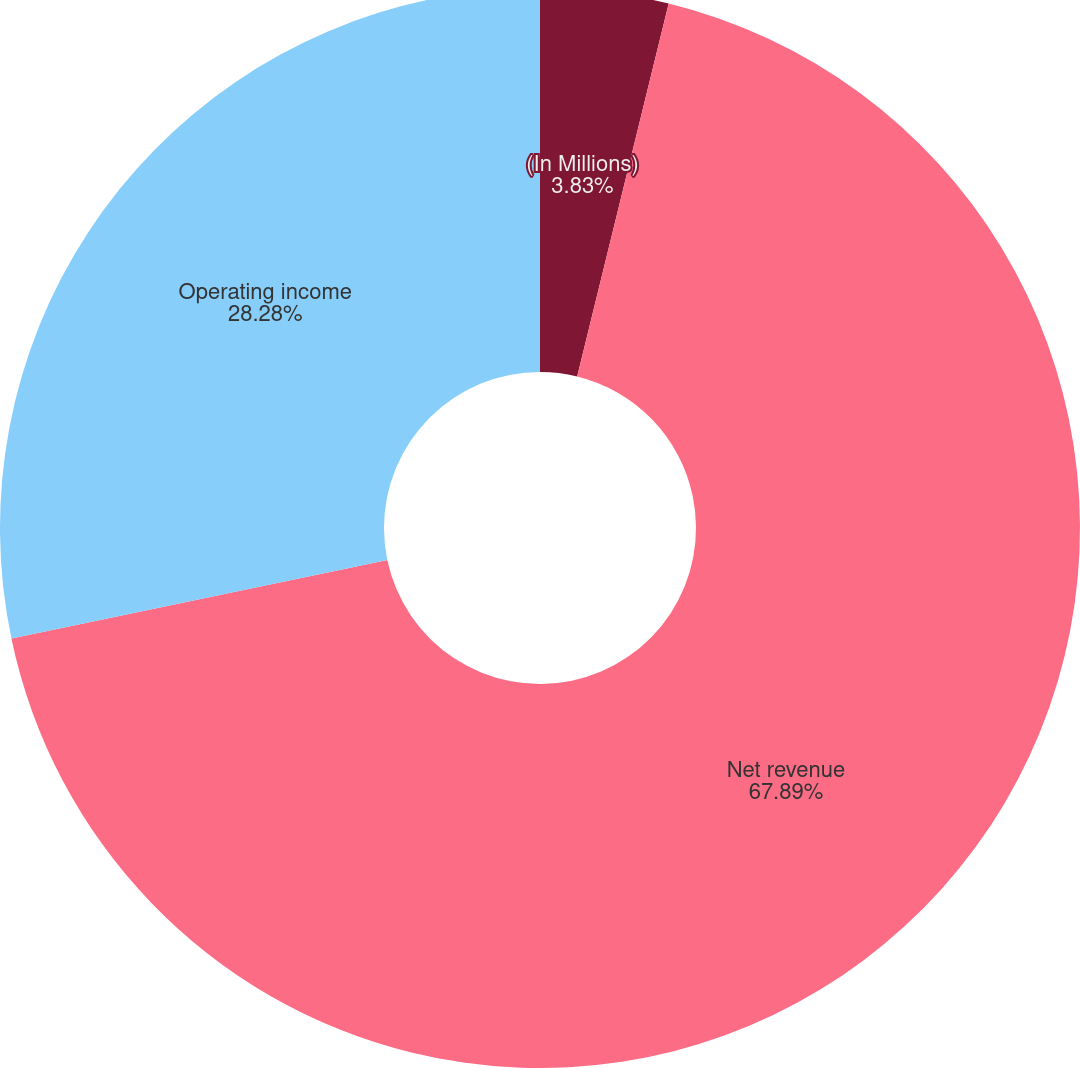Convert chart to OTSL. <chart><loc_0><loc_0><loc_500><loc_500><pie_chart><fcel>(In Millions)<fcel>Net revenue<fcel>Operating income<nl><fcel>3.83%<fcel>67.89%<fcel>28.28%<nl></chart> 